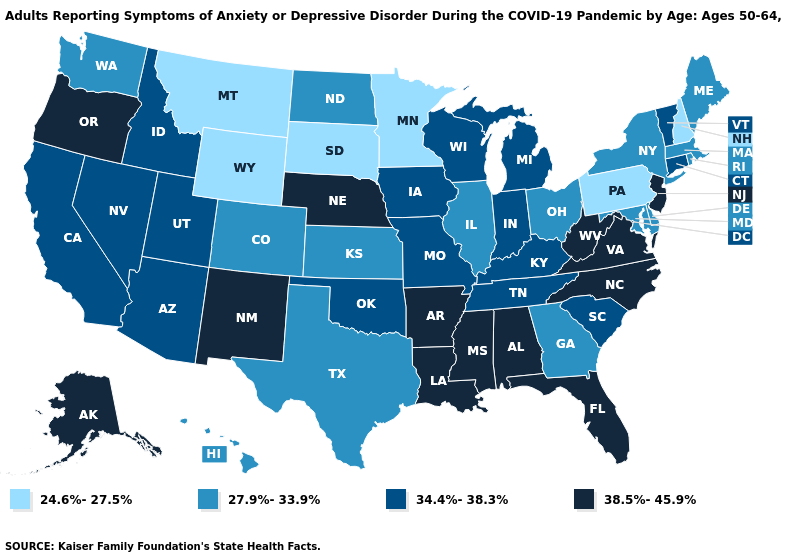What is the value of Utah?
Concise answer only. 34.4%-38.3%. What is the value of New Jersey?
Quick response, please. 38.5%-45.9%. What is the value of South Carolina?
Keep it brief. 34.4%-38.3%. Which states have the lowest value in the USA?
Give a very brief answer. Minnesota, Montana, New Hampshire, Pennsylvania, South Dakota, Wyoming. What is the value of South Dakota?
Give a very brief answer. 24.6%-27.5%. Name the states that have a value in the range 27.9%-33.9%?
Be succinct. Colorado, Delaware, Georgia, Hawaii, Illinois, Kansas, Maine, Maryland, Massachusetts, New York, North Dakota, Ohio, Rhode Island, Texas, Washington. Does Delaware have a lower value than New York?
Answer briefly. No. What is the value of Alaska?
Give a very brief answer. 38.5%-45.9%. What is the highest value in states that border Kansas?
Give a very brief answer. 38.5%-45.9%. What is the value of Ohio?
Quick response, please. 27.9%-33.9%. What is the highest value in the USA?
Give a very brief answer. 38.5%-45.9%. Name the states that have a value in the range 27.9%-33.9%?
Be succinct. Colorado, Delaware, Georgia, Hawaii, Illinois, Kansas, Maine, Maryland, Massachusetts, New York, North Dakota, Ohio, Rhode Island, Texas, Washington. Name the states that have a value in the range 34.4%-38.3%?
Be succinct. Arizona, California, Connecticut, Idaho, Indiana, Iowa, Kentucky, Michigan, Missouri, Nevada, Oklahoma, South Carolina, Tennessee, Utah, Vermont, Wisconsin. Does New Hampshire have the lowest value in the USA?
Give a very brief answer. Yes. Among the states that border South Dakota , which have the lowest value?
Give a very brief answer. Minnesota, Montana, Wyoming. 